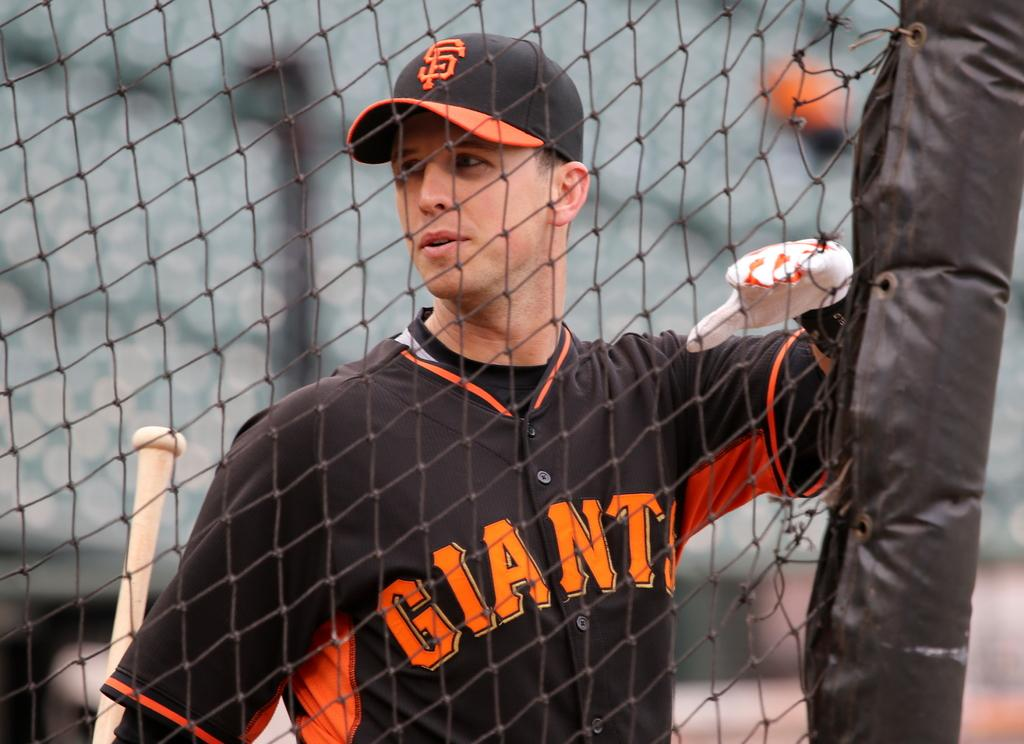<image>
Offer a succinct explanation of the picture presented. A baseball player with the SF Giants is standing at a fence. 